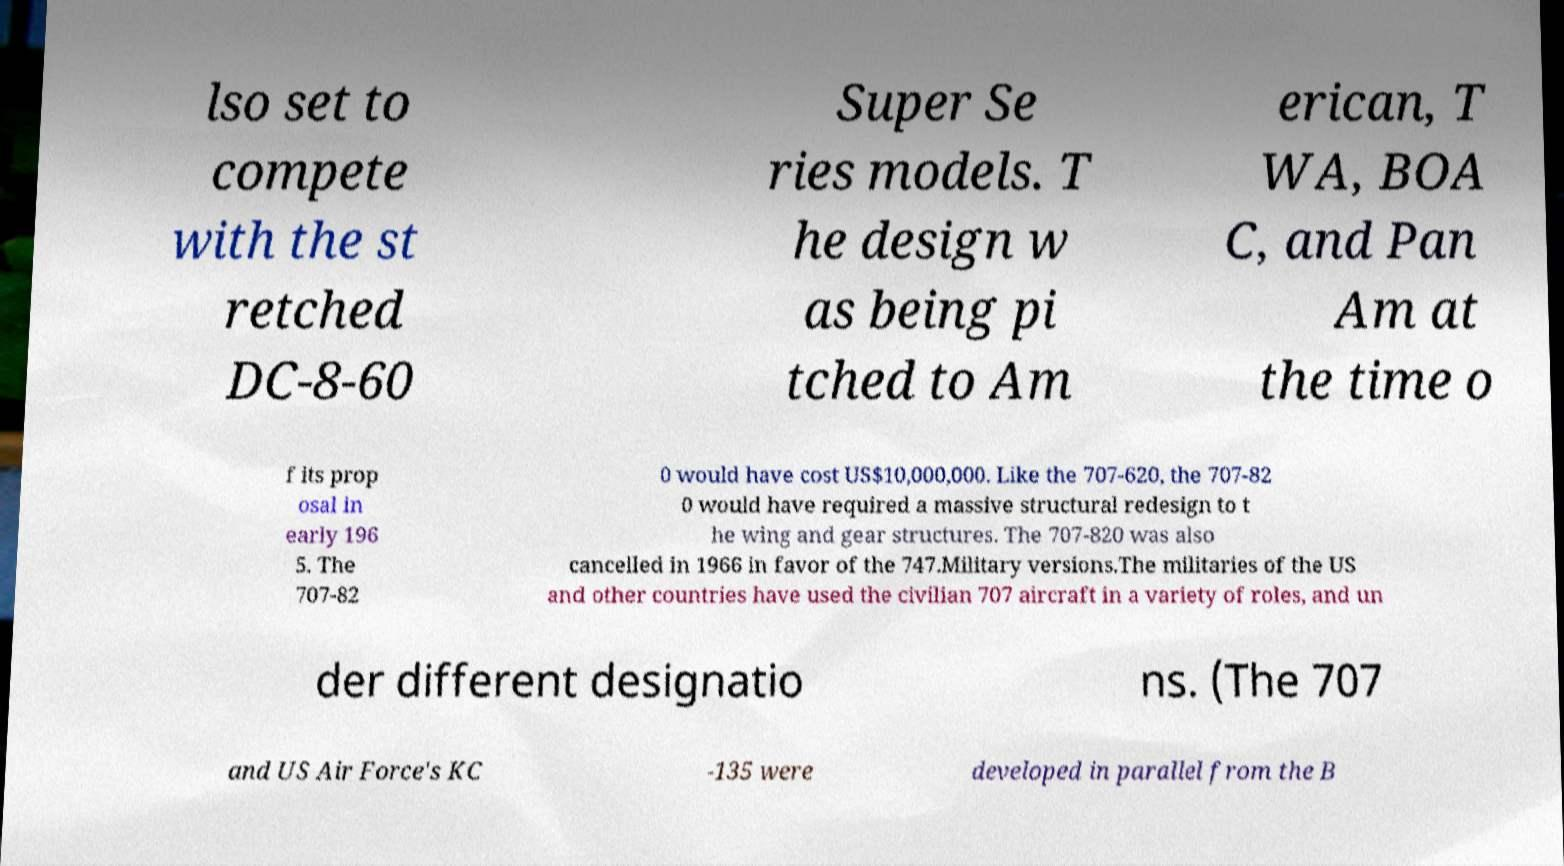Can you accurately transcribe the text from the provided image for me? lso set to compete with the st retched DC-8-60 Super Se ries models. T he design w as being pi tched to Am erican, T WA, BOA C, and Pan Am at the time o f its prop osal in early 196 5. The 707-82 0 would have cost US$10,000,000. Like the 707-620, the 707-82 0 would have required a massive structural redesign to t he wing and gear structures. The 707-820 was also cancelled in 1966 in favor of the 747.Military versions.The militaries of the US and other countries have used the civilian 707 aircraft in a variety of roles, and un der different designatio ns. (The 707 and US Air Force's KC -135 were developed in parallel from the B 